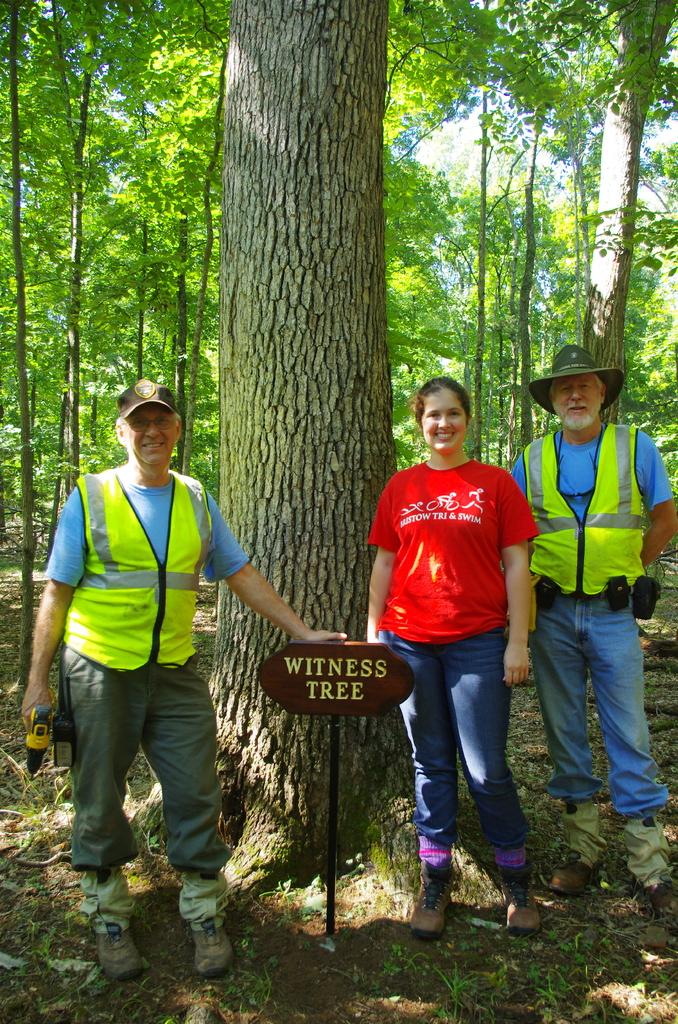How many people are in the image? There are three persons standing in the middle of the image. What is the facial expression of the persons? The persons are smiling. What can be seen in the background of the image? There are trees visible behind the persons. What type of war is depicted in the image? There is no depiction of war in the image; it features three smiling persons standing in the middle and trees in the background. 